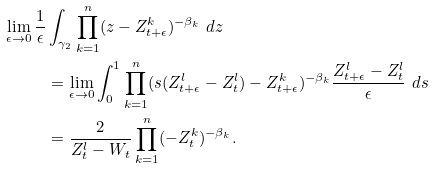<formula> <loc_0><loc_0><loc_500><loc_500>\lim _ { \epsilon \to 0 } \frac { 1 } { \epsilon } & \int _ { \gamma _ { 2 } } \prod _ { k = 1 } ^ { n } ( z - Z _ { t + \epsilon } ^ { k } ) ^ { - \beta _ { k } } \ d z \\ & = \lim _ { \epsilon \to 0 } \int _ { 0 } ^ { 1 } \prod _ { k = 1 } ^ { n } ( s ( Z _ { t + \epsilon } ^ { l } - Z _ { t } ^ { l } ) - Z _ { t + \epsilon } ^ { k } ) ^ { - \beta _ { k } } \frac { Z _ { t + \epsilon } ^ { l } - Z _ { t } ^ { l } } { \epsilon } \ d s \\ & = \frac { 2 } { Z _ { t } ^ { l } - W _ { t } } \prod _ { k = 1 } ^ { n } ( - Z _ { t } ^ { k } ) ^ { - \beta _ { k } } .</formula> 